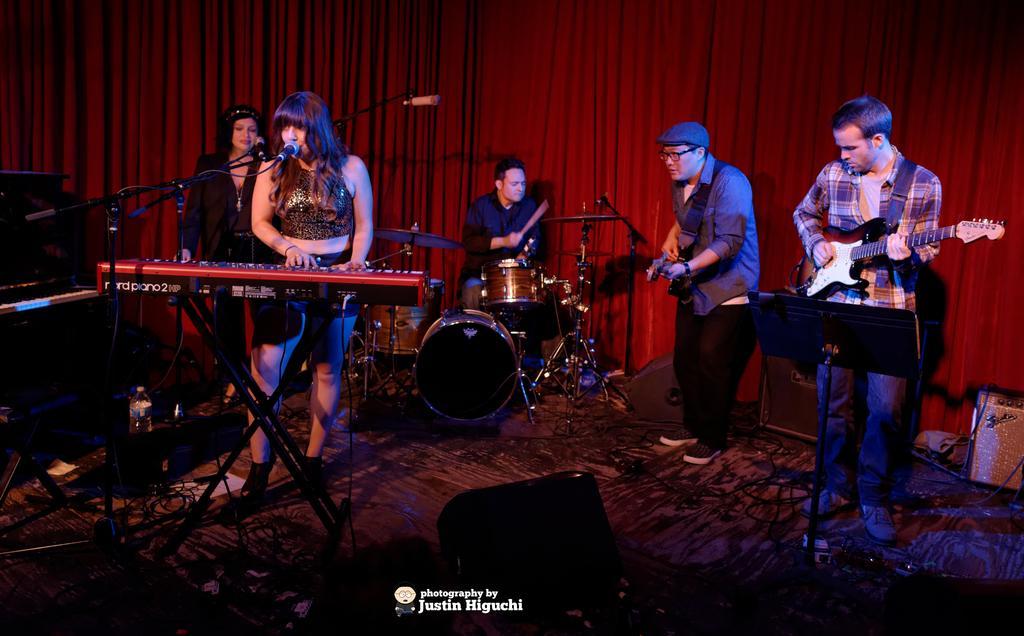In one or two sentences, can you explain what this image depicts? In this picture i can see some people performing musical show using piano, drums, guitar. In the background i could see a red curtain. 